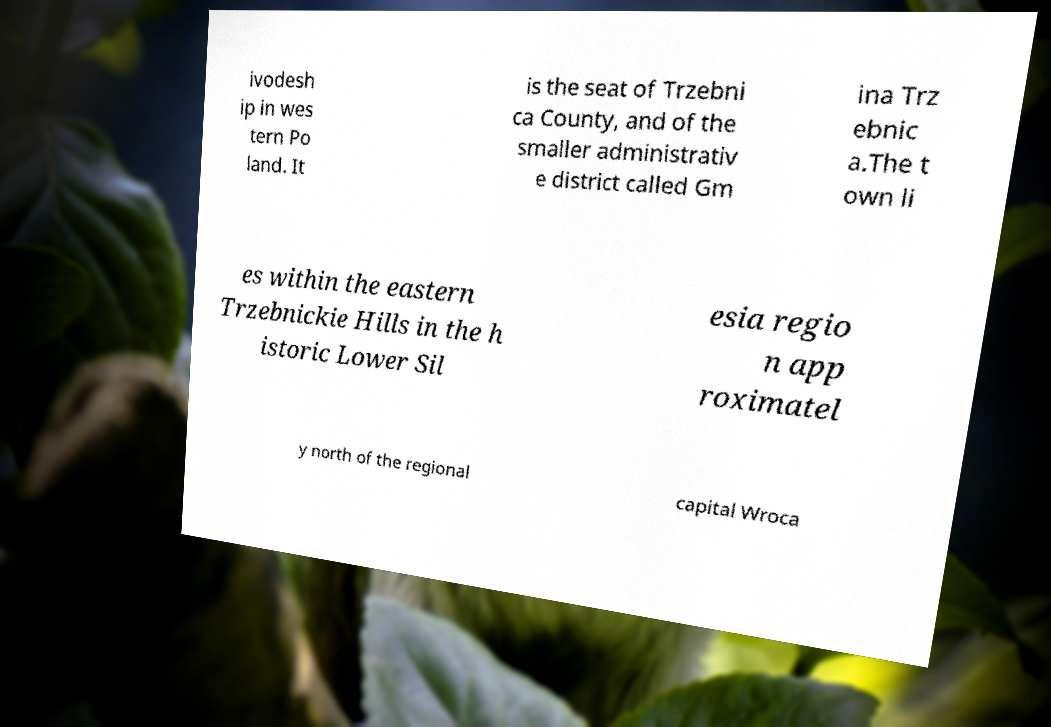I need the written content from this picture converted into text. Can you do that? ivodesh ip in wes tern Po land. It is the seat of Trzebni ca County, and of the smaller administrativ e district called Gm ina Trz ebnic a.The t own li es within the eastern Trzebnickie Hills in the h istoric Lower Sil esia regio n app roximatel y north of the regional capital Wroca 